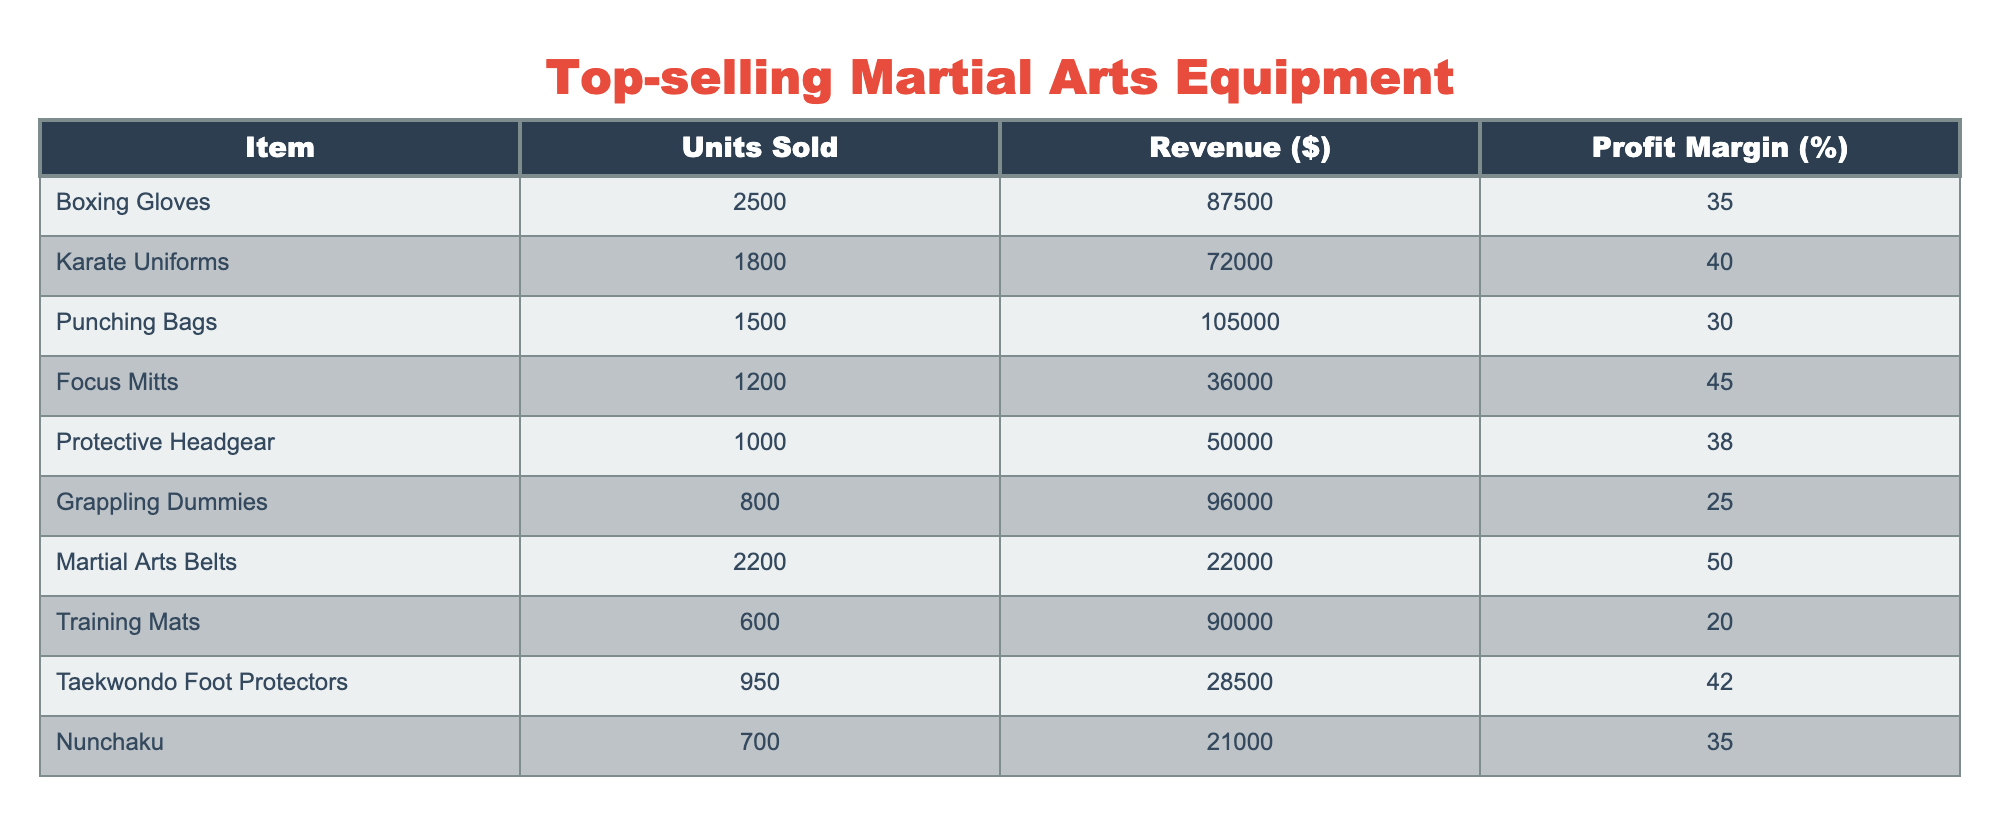What is the total revenue generated from the Boxing Gloves? The revenue for Boxing Gloves is directly listed in the table as $87,500.
Answer: $87,500 Which item has the highest profit margin? The profit margin for Boxing Gloves is 35%, Karate Uniforms is 40%, Punching Bags is 30%, Focus Mitts is 45%, Protective Headgear is 38%, Grappling Dummies is 25%, Martial Arts Belts is 50%, Training Mats is 20%, Taekwondo Foot Protectors is 42%, and Nunchaku is 35%. The highest is Martial Arts Belts at 50%.
Answer: Martial Arts Belts How many units of Punching Bags were sold compared to Focus Mitts? Punching Bags sold 1,500 units, while Focus Mitts sold 1,200 units. Subtracting gives 1,500 - 1,200 = 300, meaning more Punching Bags were sold by 300 units.
Answer: 300 more Punching Bags Is the total profit margin for all items above 30%? To find the total profit margin, we can evaluate each item's profit margin and then compare the average profit margins. The total profit margin is calculated as the sum of the profit margins divided by the number of items. The total sum is 35 + 40 + 30 + 45 + 38 + 25 + 50 + 20 + 42 + 35 =  410. There are 10 items in total, so the average is 410 / 10 = 41%. Thus, the average profit margin is above 30%.
Answer: Yes What item sold the least units, and what was its revenue? Looking at the "Units Sold" column, Nunchaku had the least sales at 700 units. To find its revenue, we can check the "Revenue" column for Nunchaku, which is $21,000.
Answer: Nunchaku, $21,000 What is the average revenue generated from all items? The revenue values are $87,500, $72,000, $105,000, $36,000, $50,000, $96,000, $22,000, $90,000, $28,500, and $21,000. Summing these gives $87,500 + $72,000 + $105,000 + $36,000 + $50,000 + $96,000 + $22,000 + $90,000 + $28,500 + $21,000 = $588,000. Dividing this by the number of items (10) yields an average of $58,800.
Answer: $58,800 Which two items together generated the highest revenue? First, we can analyze the revenue of each item and find the two highest: Punching Bags at $105,000 and Boxing Gloves at $87,500. Adding these two together gives $105,000 + $87,500 = $192,500.
Answer: $192,500 What percentage of total units sold were Martial Arts Belts? The total units sold across all items are 2500 + 1800 + 1500 + 1200 + 1000 + 800 + 2200 + 600 + 950 + 700 = 13,250. The units sold for Martial Arts Belts is 2,200. The percentage is calculated as (2,200 / 13,250) * 100, which is approximately 16.6%.
Answer: 16.6% 